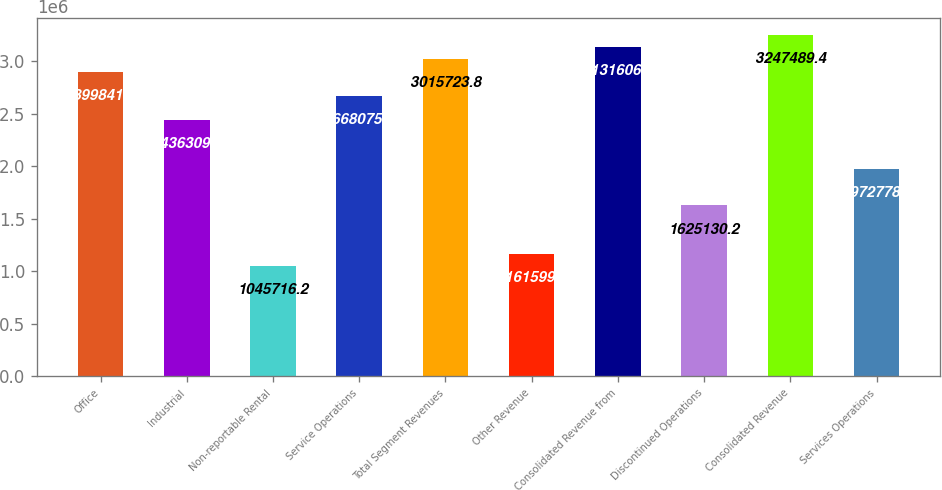Convert chart to OTSL. <chart><loc_0><loc_0><loc_500><loc_500><bar_chart><fcel>Office<fcel>Industrial<fcel>Non-reportable Rental<fcel>Service Operations<fcel>Total Segment Revenues<fcel>Other Revenue<fcel>Consolidated Revenue from<fcel>Discontinued Operations<fcel>Consolidated Revenue<fcel>Services Operations<nl><fcel>2.89984e+06<fcel>2.43631e+06<fcel>1.04572e+06<fcel>2.66808e+06<fcel>3.01572e+06<fcel>1.1616e+06<fcel>3.13161e+06<fcel>1.62513e+06<fcel>3.24749e+06<fcel>1.97278e+06<nl></chart> 